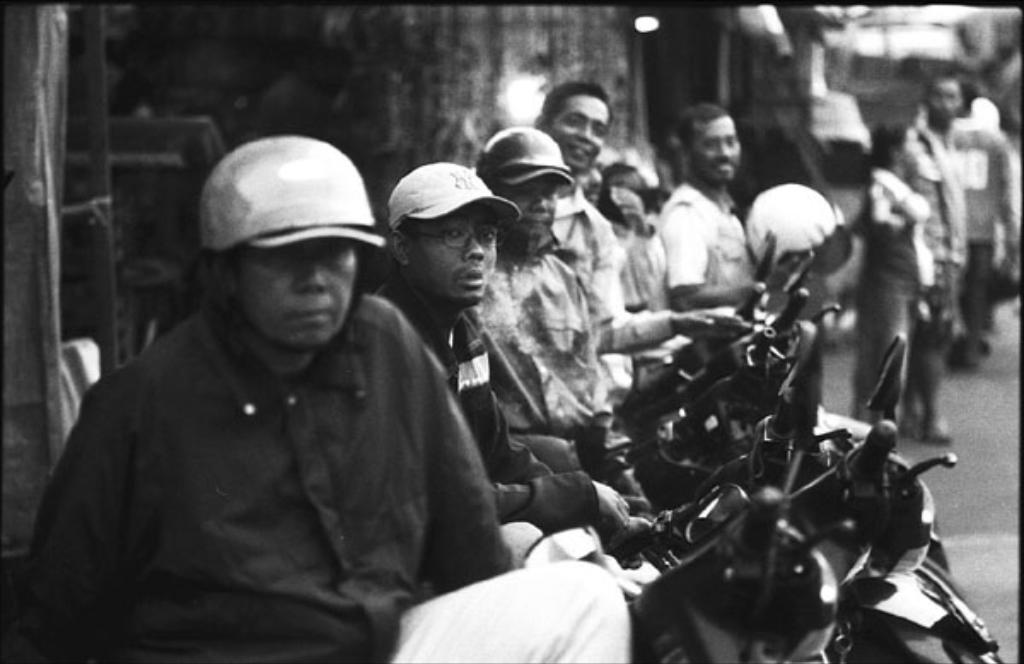Could you give a brief overview of what you see in this image? This is a black and white picture, in this image we can see a few people, among them some are sitting on motor bikes and some are standing, the background is blurred. 